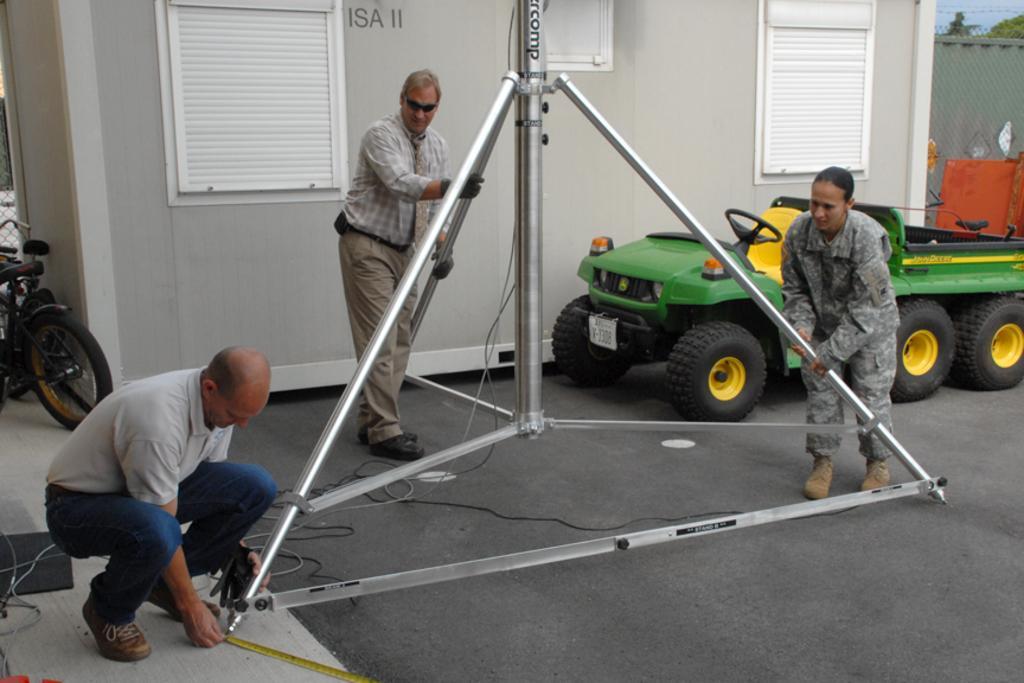How would you summarize this image in a sentence or two? In this image there are two men and a woman are working with iron rods, in the background there is a vehicle, bicycle and a shed. 